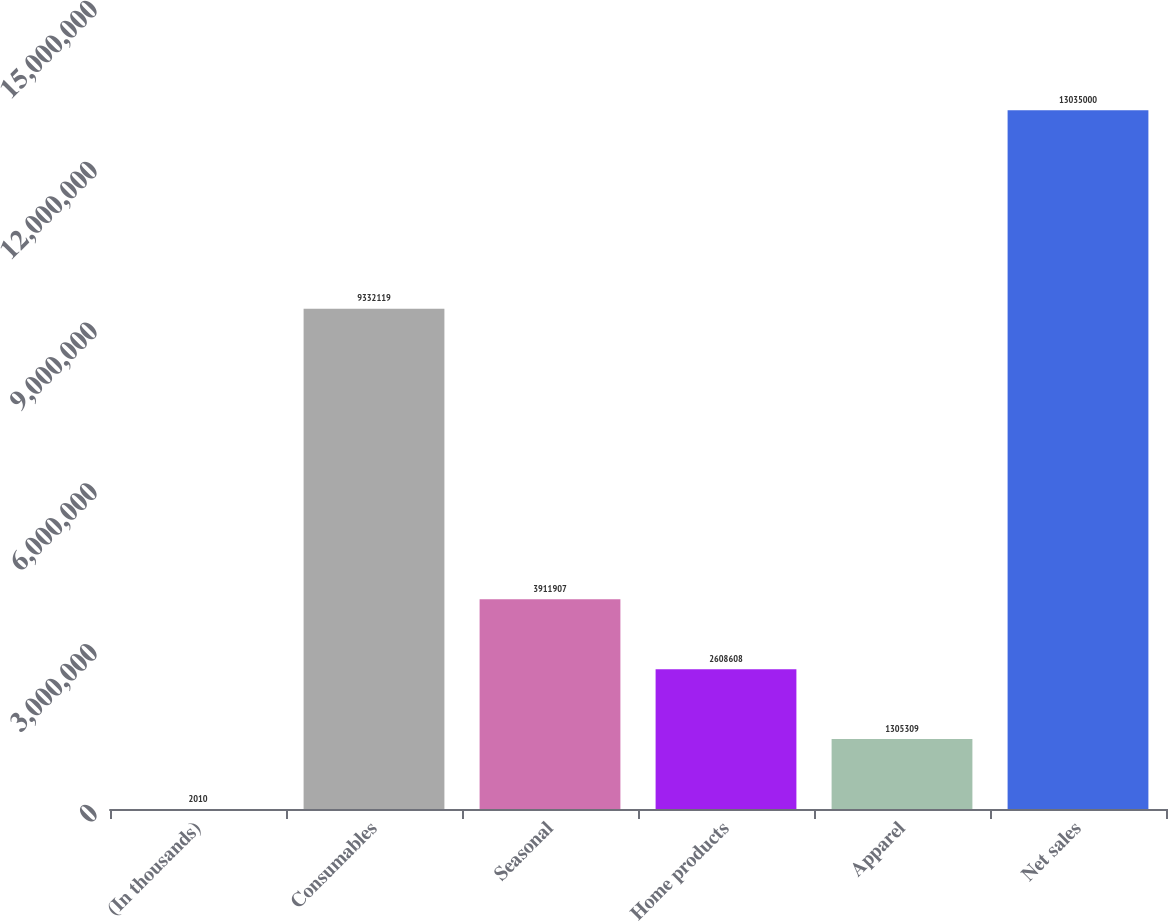<chart> <loc_0><loc_0><loc_500><loc_500><bar_chart><fcel>(In thousands)<fcel>Consumables<fcel>Seasonal<fcel>Home products<fcel>Apparel<fcel>Net sales<nl><fcel>2010<fcel>9.33212e+06<fcel>3.91191e+06<fcel>2.60861e+06<fcel>1.30531e+06<fcel>1.3035e+07<nl></chart> 